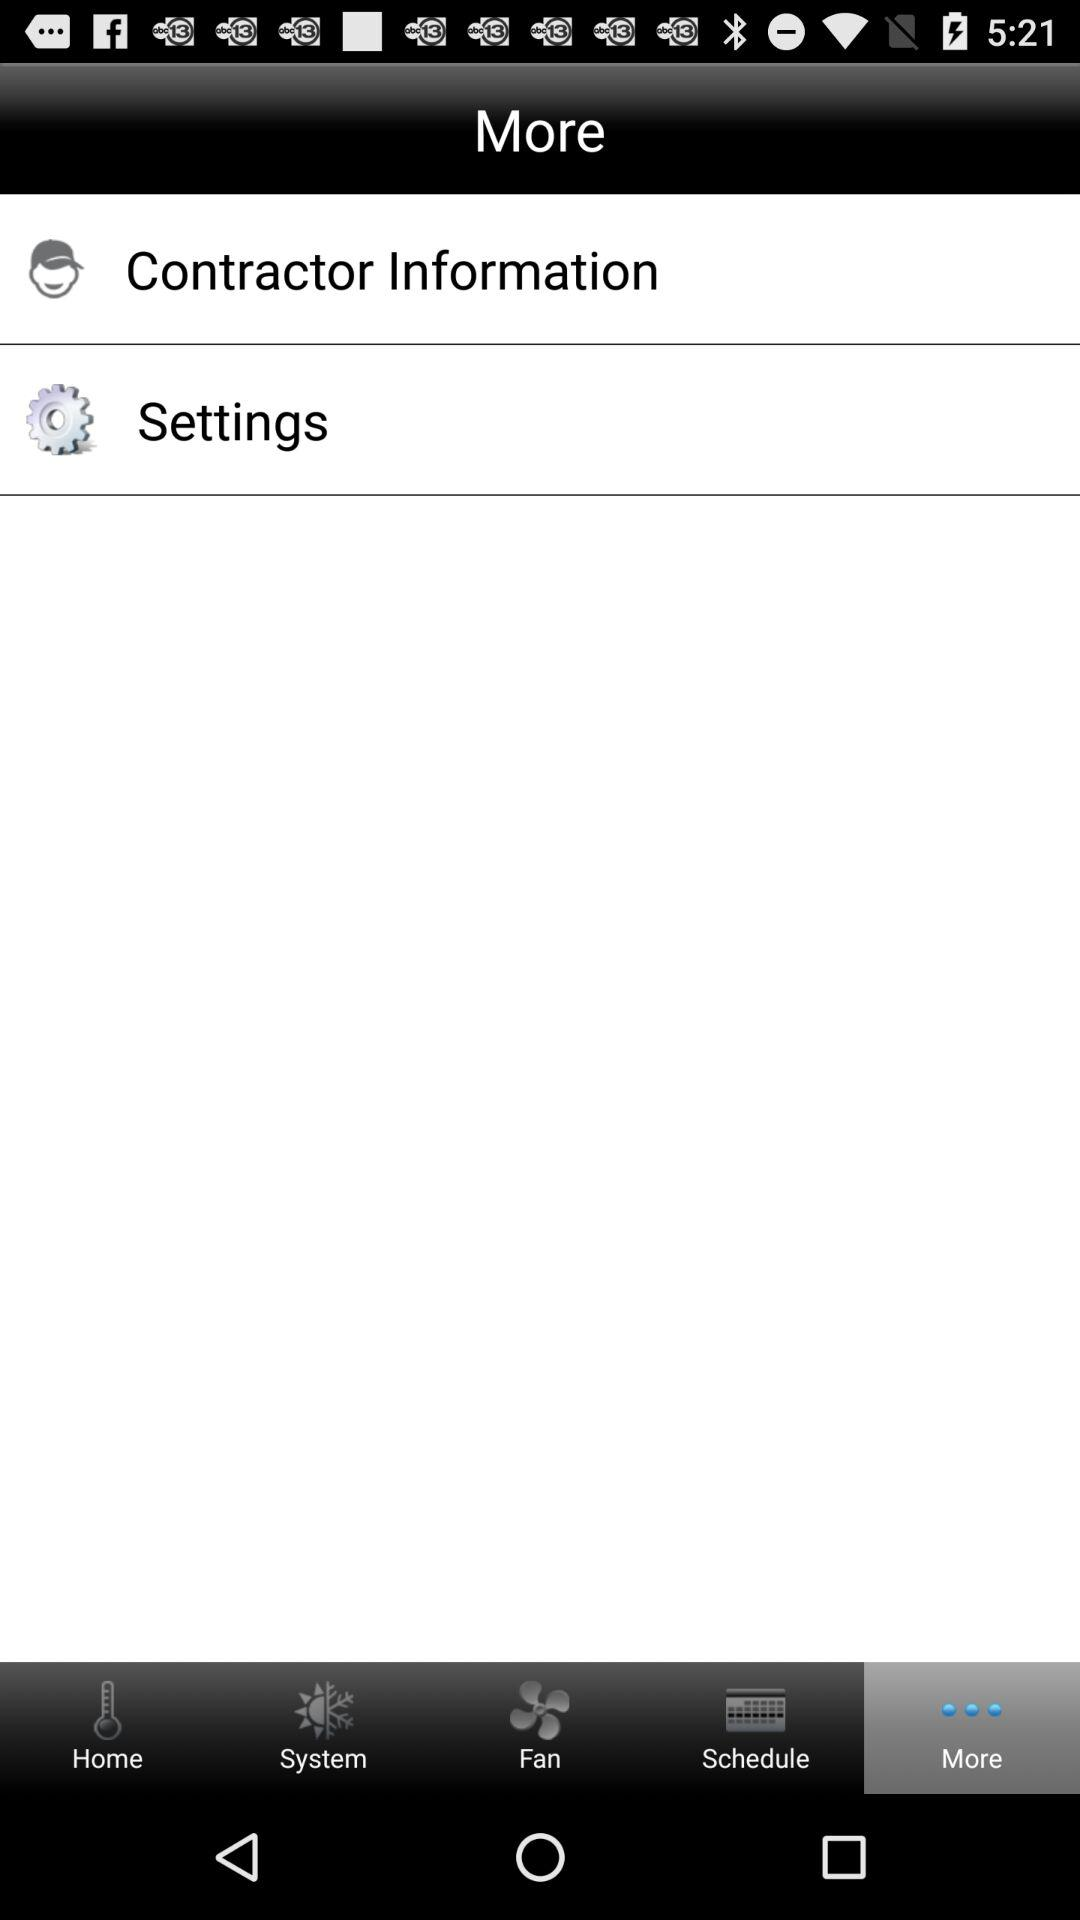Which tab am I on? You are on the "More" tab. 